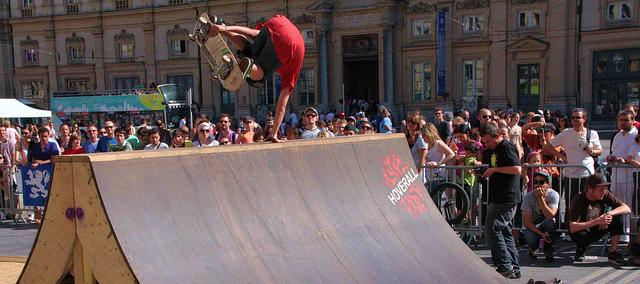What maneuver is the man wearing red performing? skateboard trick 